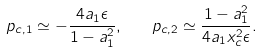<formula> <loc_0><loc_0><loc_500><loc_500>p _ { c , 1 } \simeq - \frac { 4 a _ { 1 } \epsilon } { 1 - a _ { 1 } ^ { 2 } } , \quad p _ { c , 2 } \simeq \frac { 1 - a _ { 1 } ^ { 2 } } { 4 a _ { 1 } x _ { c } ^ { 2 } \epsilon } .</formula> 